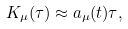Convert formula to latex. <formula><loc_0><loc_0><loc_500><loc_500>K _ { \mu } ( \tau ) \approx a _ { \mu } ( t ) \tau ,</formula> 